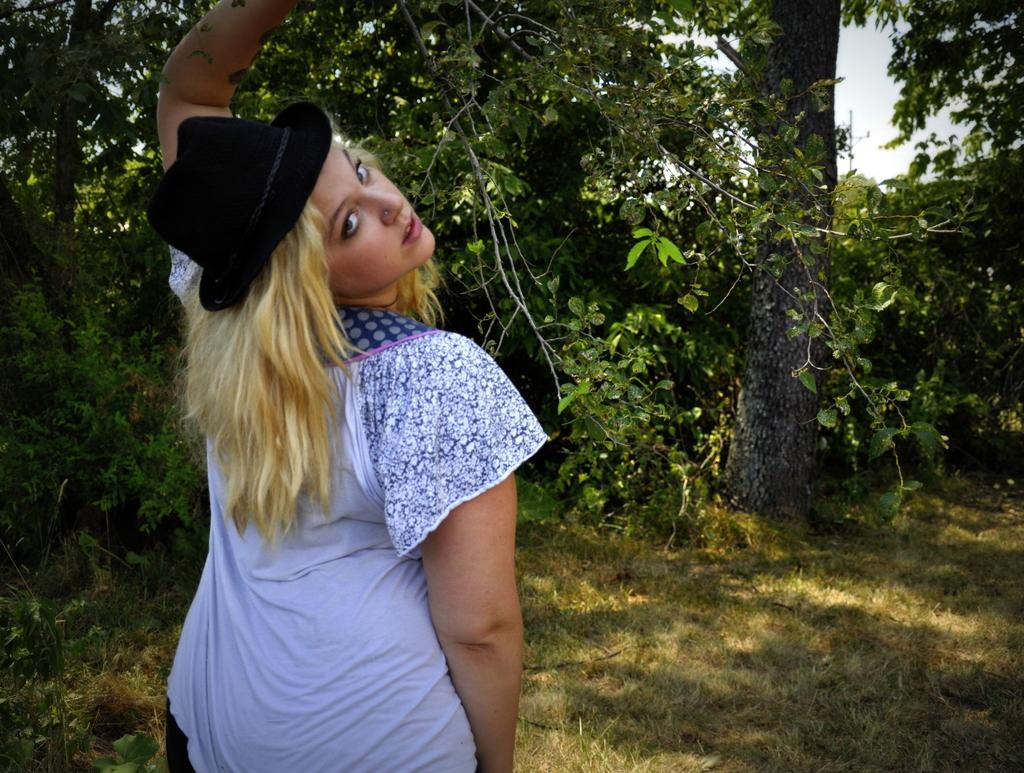What is the main subject of the image? There is a person standing in the image. What is the person wearing? The person is wearing a black and white dress and a white cap. What can be seen in the background of the image? There are trees and the sky visible in the background of the image. What is the color of the trees in the image? The trees are green. What is the color of the sky in the image? The sky is white. How many fans are visible in the image? There are no fans present in the image. Are there any brothers in the image? There is no mention of brothers or any other people besides the person standing in the image. 